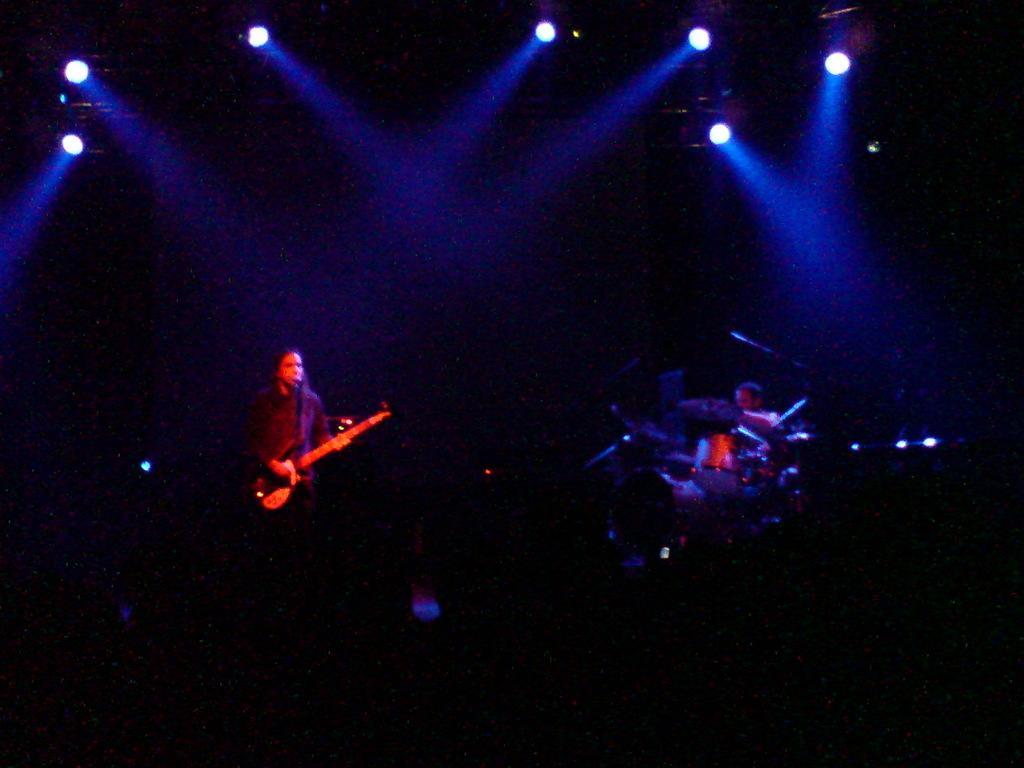Please provide a concise description of this image. In this picture we can see persons,here we can see musical instruments and in the background we can see lights. 